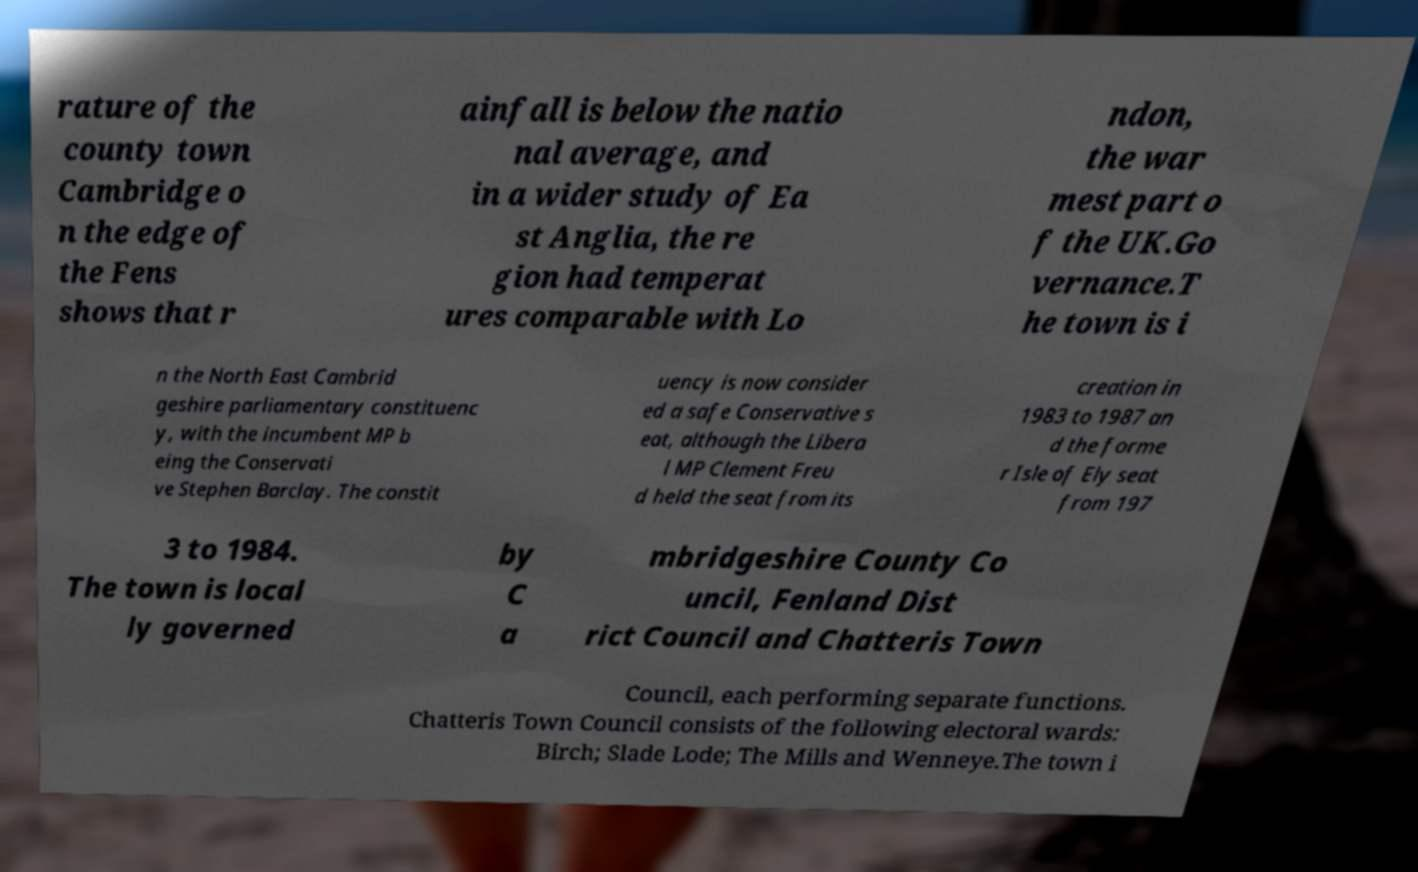Could you assist in decoding the text presented in this image and type it out clearly? rature of the county town Cambridge o n the edge of the Fens shows that r ainfall is below the natio nal average, and in a wider study of Ea st Anglia, the re gion had temperat ures comparable with Lo ndon, the war mest part o f the UK.Go vernance.T he town is i n the North East Cambrid geshire parliamentary constituenc y, with the incumbent MP b eing the Conservati ve Stephen Barclay. The constit uency is now consider ed a safe Conservative s eat, although the Libera l MP Clement Freu d held the seat from its creation in 1983 to 1987 an d the forme r Isle of Ely seat from 197 3 to 1984. The town is local ly governed by C a mbridgeshire County Co uncil, Fenland Dist rict Council and Chatteris Town Council, each performing separate functions. Chatteris Town Council consists of the following electoral wards: Birch; Slade Lode; The Mills and Wenneye.The town i 